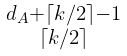Convert formula to latex. <formula><loc_0><loc_0><loc_500><loc_500>\begin{smallmatrix} d _ { A } + \lceil k / 2 \rceil - 1 \\ \lceil k / 2 \rceil \end{smallmatrix}</formula> 